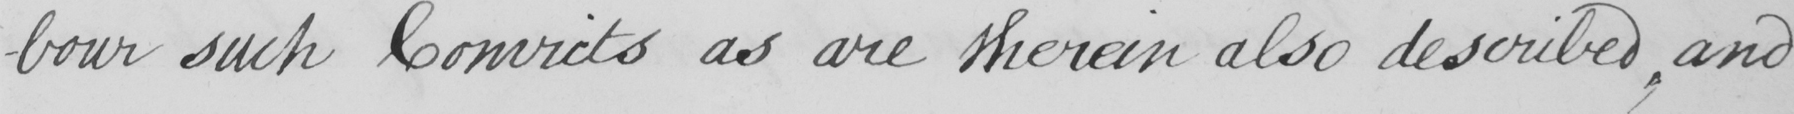What is written in this line of handwriting? -bour such Convicts as are therein also described , and 